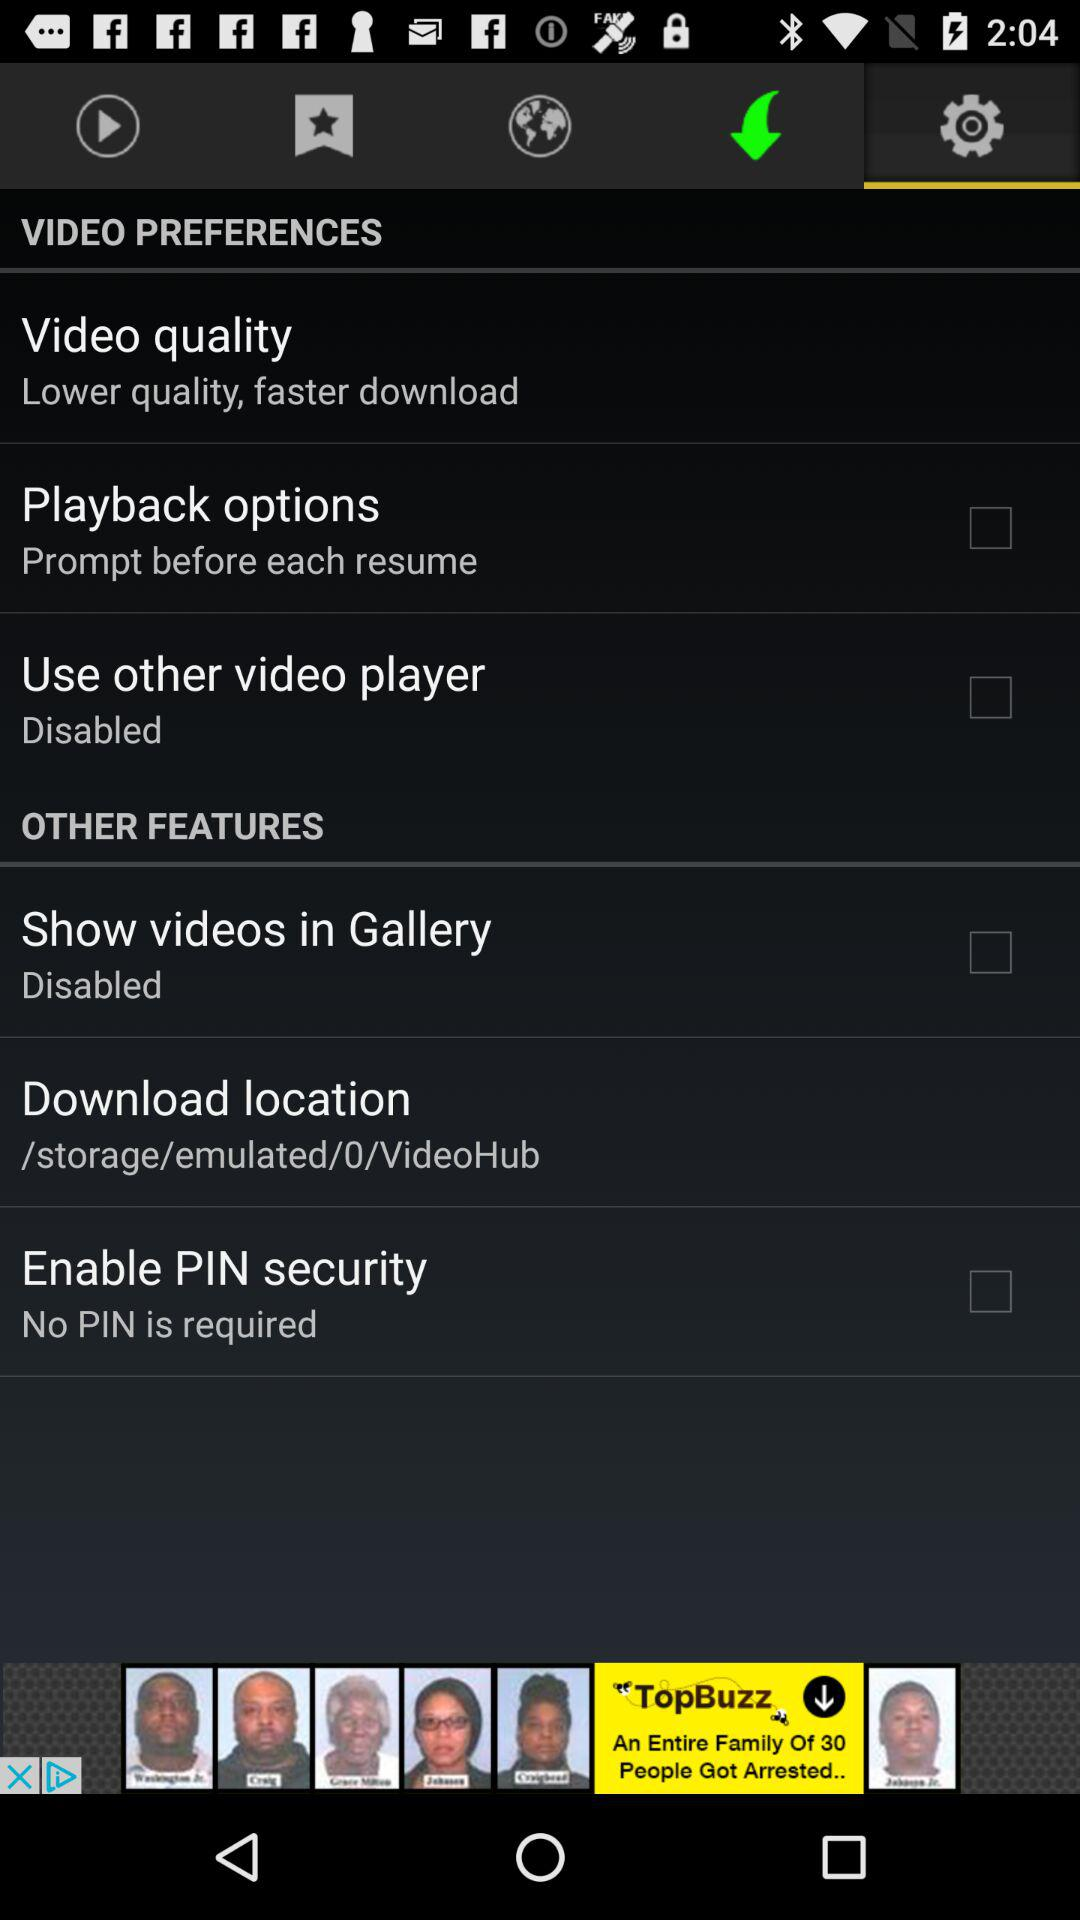What is the status of "Enable PIN security"? The status is "off". 